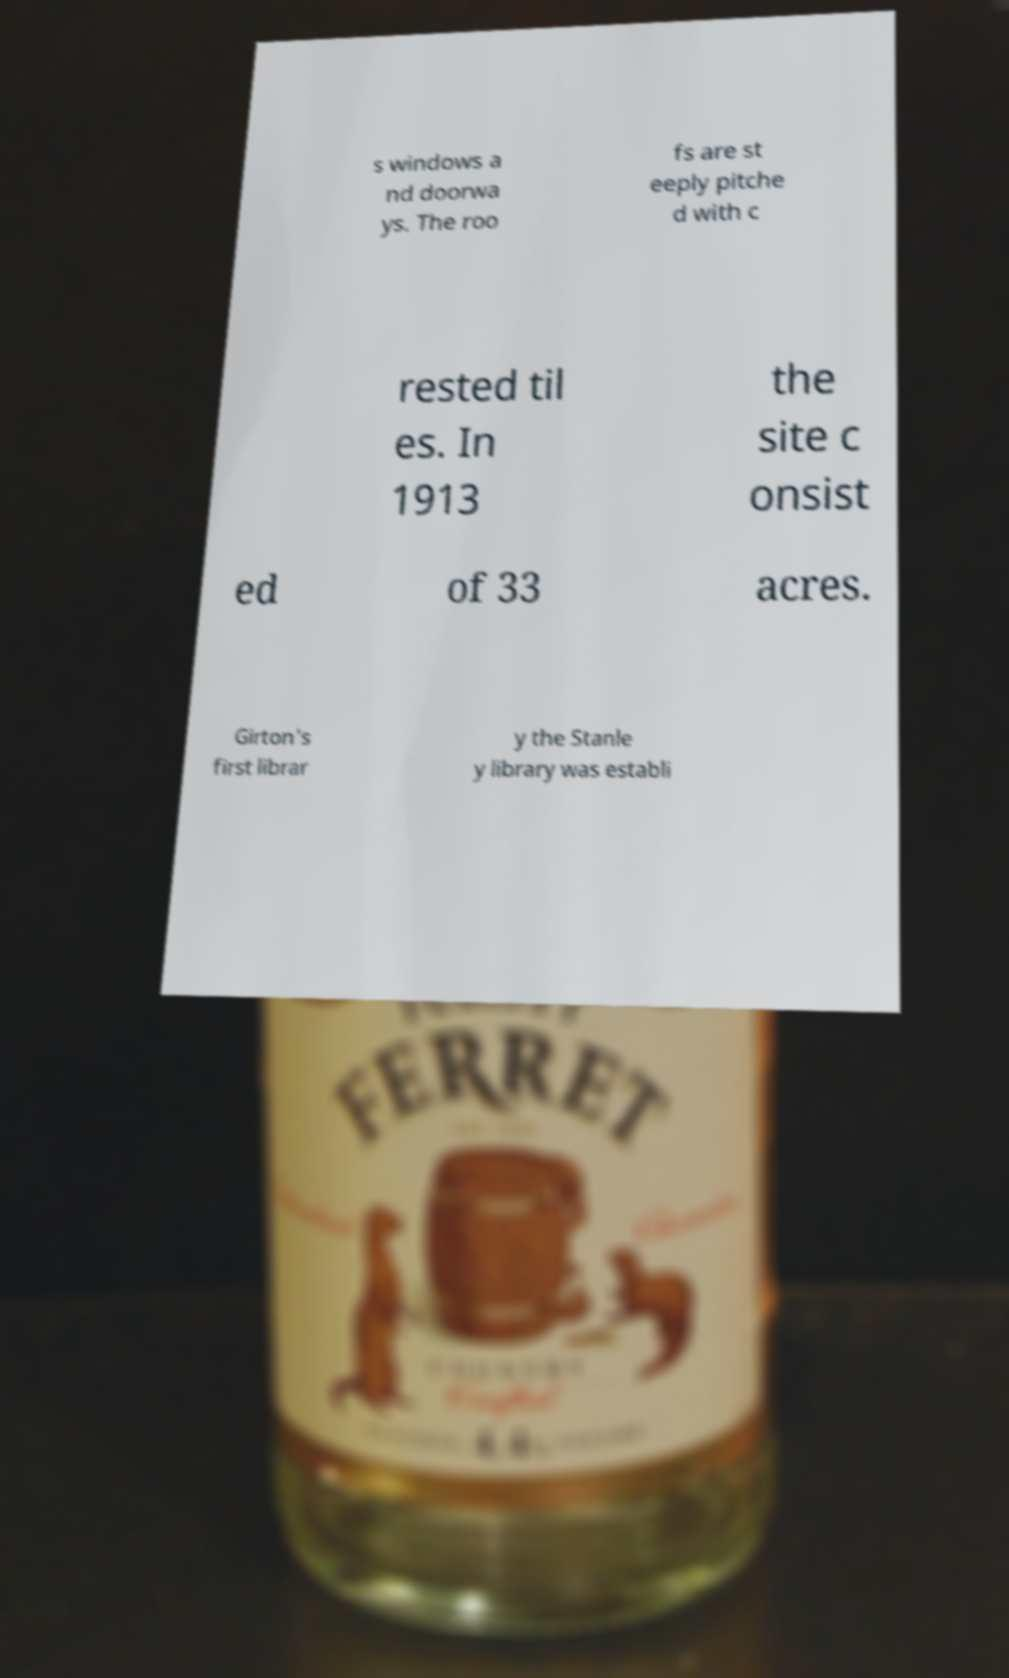Could you extract and type out the text from this image? s windows a nd doorwa ys. The roo fs are st eeply pitche d with c rested til es. In 1913 the site c onsist ed of 33 acres. Girton's first librar y the Stanle y library was establi 